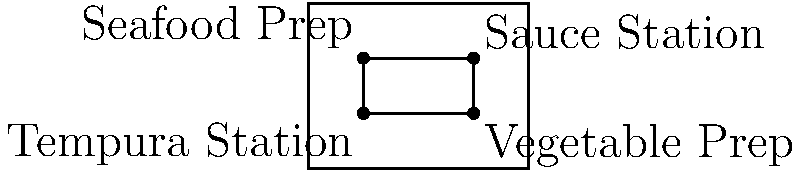In a kitchen layout diagram, four ingredient preparation stations for tempura are represented by the points: Tempura Station (2,2), Vegetable Prep (6,2), Sauce Station (6,4), and Seafood Prep (2,4). The chef wants to install a central workstation at the intersection of the diagonals connecting these stations. What are the coordinates of this central workstation? To find the intersection point of the diagonals, we need to follow these steps:

1) Identify the diagonals:
   Diagonal 1: Tempura Station (2,2) to Sauce Station (6,4)
   Diagonal 2: Vegetable Prep (6,2) to Seafood Prep (2,4)

2) Find the equations of these lines:
   For Diagonal 1: 
   Slope = $\frac{4-2}{6-2} = \frac{1}{2}$
   Equation: $y - 2 = \frac{1}{2}(x - 2)$ or $y = \frac{1}{2}x + 1$

   For Diagonal 2:
   Slope = $\frac{4-2}{2-6} = -\frac{1}{2}$
   Equation: $y - 2 = -\frac{1}{2}(x - 6)$ or $y = -\frac{1}{2}x + 5$

3) Solve these equations simultaneously to find the intersection point:
   $\frac{1}{2}x + 1 = -\frac{1}{2}x + 5$
   $x + 2 = -x + 10$
   $2x = 8$
   $x = 4$

   Substitute this x-value into either equation:
   $y = \frac{1}{2}(4) + 1 = 3$

4) Therefore, the intersection point is (4,3).
Answer: (4,3) 